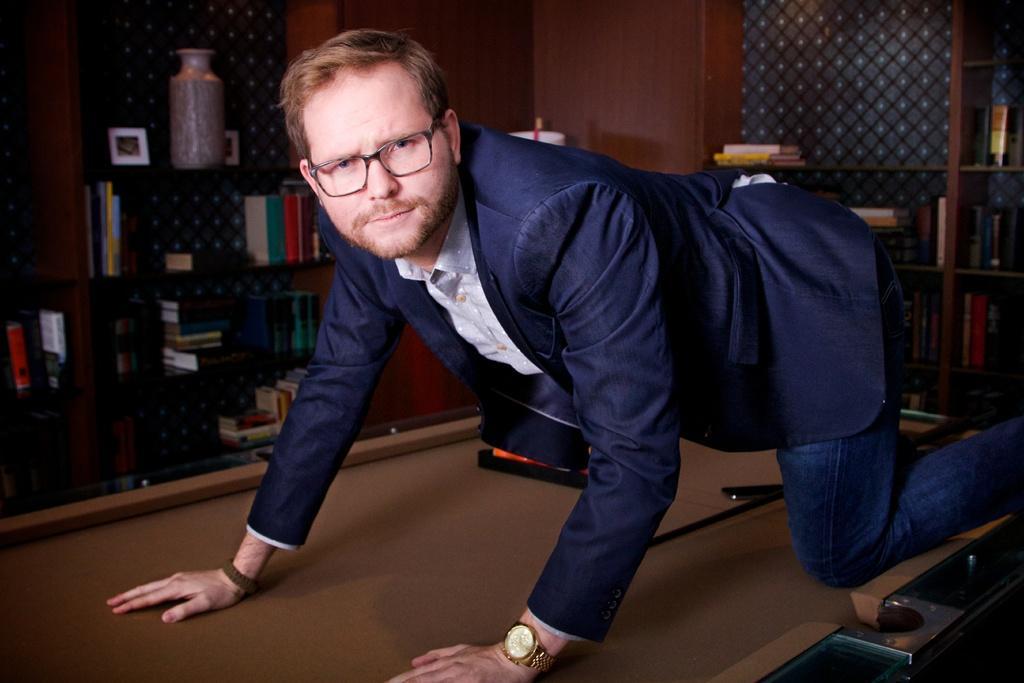In one or two sentences, can you explain what this image depicts? a person is the crawling position on a table. behind him there are bookshelves. 